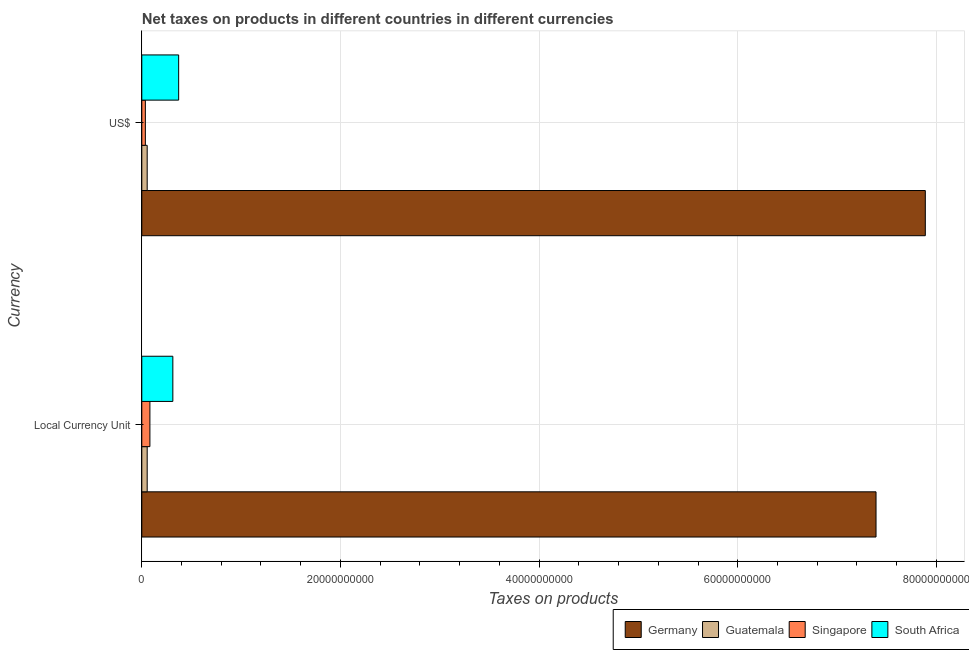How many different coloured bars are there?
Give a very brief answer. 4. Are the number of bars per tick equal to the number of legend labels?
Provide a short and direct response. Yes. How many bars are there on the 1st tick from the top?
Keep it short and to the point. 4. How many bars are there on the 2nd tick from the bottom?
Your answer should be compact. 4. What is the label of the 2nd group of bars from the top?
Make the answer very short. Local Currency Unit. What is the net taxes in us$ in Germany?
Make the answer very short. 7.89e+1. Across all countries, what is the maximum net taxes in us$?
Give a very brief answer. 7.89e+1. Across all countries, what is the minimum net taxes in us$?
Keep it short and to the point. 3.59e+08. In which country was the net taxes in us$ maximum?
Offer a terse response. Germany. In which country was the net taxes in constant 2005 us$ minimum?
Provide a short and direct response. Guatemala. What is the total net taxes in constant 2005 us$ in the graph?
Offer a very short reply. 7.84e+1. What is the difference between the net taxes in us$ in Germany and that in Guatemala?
Your answer should be very brief. 7.83e+1. What is the difference between the net taxes in us$ in Germany and the net taxes in constant 2005 us$ in South Africa?
Give a very brief answer. 7.58e+1. What is the average net taxes in us$ per country?
Offer a terse response. 2.09e+1. What is the difference between the net taxes in us$ and net taxes in constant 2005 us$ in Germany?
Offer a terse response. 4.96e+09. In how many countries, is the net taxes in constant 2005 us$ greater than 4000000000 units?
Ensure brevity in your answer.  1. What is the ratio of the net taxes in us$ in Guatemala to that in South Africa?
Offer a very short reply. 0.15. Is the net taxes in us$ in Singapore less than that in Germany?
Your answer should be compact. Yes. What does the 4th bar from the top in US$ represents?
Provide a succinct answer. Germany. What does the 2nd bar from the bottom in Local Currency Unit represents?
Offer a very short reply. Guatemala. How many countries are there in the graph?
Ensure brevity in your answer.  4. Where does the legend appear in the graph?
Offer a very short reply. Bottom right. How many legend labels are there?
Provide a short and direct response. 4. What is the title of the graph?
Offer a very short reply. Net taxes on products in different countries in different currencies. What is the label or title of the X-axis?
Offer a terse response. Taxes on products. What is the label or title of the Y-axis?
Your response must be concise. Currency. What is the Taxes on products in Germany in Local Currency Unit?
Give a very brief answer. 7.39e+1. What is the Taxes on products of Guatemala in Local Currency Unit?
Your answer should be very brief. 5.43e+08. What is the Taxes on products in Singapore in Local Currency Unit?
Ensure brevity in your answer.  8.16e+08. What is the Taxes on products of South Africa in Local Currency Unit?
Your response must be concise. 3.12e+09. What is the Taxes on products of Germany in US$?
Ensure brevity in your answer.  7.89e+1. What is the Taxes on products of Guatemala in US$?
Your answer should be compact. 5.43e+08. What is the Taxes on products of Singapore in US$?
Provide a short and direct response. 3.59e+08. What is the Taxes on products in South Africa in US$?
Make the answer very short. 3.71e+09. Across all Currency, what is the maximum Taxes on products in Germany?
Your answer should be compact. 7.89e+1. Across all Currency, what is the maximum Taxes on products in Guatemala?
Give a very brief answer. 5.43e+08. Across all Currency, what is the maximum Taxes on products of Singapore?
Offer a terse response. 8.16e+08. Across all Currency, what is the maximum Taxes on products in South Africa?
Offer a very short reply. 3.71e+09. Across all Currency, what is the minimum Taxes on products of Germany?
Ensure brevity in your answer.  7.39e+1. Across all Currency, what is the minimum Taxes on products of Guatemala?
Provide a short and direct response. 5.43e+08. Across all Currency, what is the minimum Taxes on products of Singapore?
Give a very brief answer. 3.59e+08. Across all Currency, what is the minimum Taxes on products of South Africa?
Ensure brevity in your answer.  3.12e+09. What is the total Taxes on products in Germany in the graph?
Your response must be concise. 1.53e+11. What is the total Taxes on products in Guatemala in the graph?
Your answer should be very brief. 1.09e+09. What is the total Taxes on products of Singapore in the graph?
Your answer should be very brief. 1.17e+09. What is the total Taxes on products in South Africa in the graph?
Keep it short and to the point. 6.84e+09. What is the difference between the Taxes on products of Germany in Local Currency Unit and that in US$?
Your answer should be very brief. -4.96e+09. What is the difference between the Taxes on products in Guatemala in Local Currency Unit and that in US$?
Ensure brevity in your answer.  0. What is the difference between the Taxes on products in Singapore in Local Currency Unit and that in US$?
Your response must be concise. 4.57e+08. What is the difference between the Taxes on products in South Africa in Local Currency Unit and that in US$?
Your answer should be compact. -5.86e+08. What is the difference between the Taxes on products of Germany in Local Currency Unit and the Taxes on products of Guatemala in US$?
Your answer should be very brief. 7.34e+1. What is the difference between the Taxes on products in Germany in Local Currency Unit and the Taxes on products in Singapore in US$?
Make the answer very short. 7.36e+1. What is the difference between the Taxes on products in Germany in Local Currency Unit and the Taxes on products in South Africa in US$?
Keep it short and to the point. 7.02e+1. What is the difference between the Taxes on products in Guatemala in Local Currency Unit and the Taxes on products in Singapore in US$?
Make the answer very short. 1.84e+08. What is the difference between the Taxes on products of Guatemala in Local Currency Unit and the Taxes on products of South Africa in US$?
Your response must be concise. -3.17e+09. What is the difference between the Taxes on products of Singapore in Local Currency Unit and the Taxes on products of South Africa in US$?
Your answer should be very brief. -2.90e+09. What is the average Taxes on products of Germany per Currency?
Offer a terse response. 7.64e+1. What is the average Taxes on products of Guatemala per Currency?
Offer a terse response. 5.43e+08. What is the average Taxes on products of Singapore per Currency?
Give a very brief answer. 5.87e+08. What is the average Taxes on products of South Africa per Currency?
Your answer should be compact. 3.42e+09. What is the difference between the Taxes on products in Germany and Taxes on products in Guatemala in Local Currency Unit?
Make the answer very short. 7.34e+1. What is the difference between the Taxes on products in Germany and Taxes on products in Singapore in Local Currency Unit?
Ensure brevity in your answer.  7.31e+1. What is the difference between the Taxes on products of Germany and Taxes on products of South Africa in Local Currency Unit?
Your answer should be very brief. 7.08e+1. What is the difference between the Taxes on products in Guatemala and Taxes on products in Singapore in Local Currency Unit?
Your answer should be very brief. -2.73e+08. What is the difference between the Taxes on products in Guatemala and Taxes on products in South Africa in Local Currency Unit?
Provide a short and direct response. -2.58e+09. What is the difference between the Taxes on products in Singapore and Taxes on products in South Africa in Local Currency Unit?
Your response must be concise. -2.31e+09. What is the difference between the Taxes on products in Germany and Taxes on products in Guatemala in US$?
Provide a succinct answer. 7.83e+1. What is the difference between the Taxes on products in Germany and Taxes on products in Singapore in US$?
Your response must be concise. 7.85e+1. What is the difference between the Taxes on products in Germany and Taxes on products in South Africa in US$?
Your response must be concise. 7.52e+1. What is the difference between the Taxes on products in Guatemala and Taxes on products in Singapore in US$?
Offer a terse response. 1.84e+08. What is the difference between the Taxes on products in Guatemala and Taxes on products in South Africa in US$?
Offer a terse response. -3.17e+09. What is the difference between the Taxes on products of Singapore and Taxes on products of South Africa in US$?
Provide a short and direct response. -3.35e+09. What is the ratio of the Taxes on products in Germany in Local Currency Unit to that in US$?
Offer a terse response. 0.94. What is the ratio of the Taxes on products of Guatemala in Local Currency Unit to that in US$?
Make the answer very short. 1. What is the ratio of the Taxes on products in Singapore in Local Currency Unit to that in US$?
Your answer should be very brief. 2.27. What is the ratio of the Taxes on products in South Africa in Local Currency Unit to that in US$?
Ensure brevity in your answer.  0.84. What is the difference between the highest and the second highest Taxes on products in Germany?
Your response must be concise. 4.96e+09. What is the difference between the highest and the second highest Taxes on products in Singapore?
Provide a succinct answer. 4.57e+08. What is the difference between the highest and the second highest Taxes on products of South Africa?
Your answer should be very brief. 5.86e+08. What is the difference between the highest and the lowest Taxes on products of Germany?
Make the answer very short. 4.96e+09. What is the difference between the highest and the lowest Taxes on products of Guatemala?
Offer a very short reply. 0. What is the difference between the highest and the lowest Taxes on products in Singapore?
Give a very brief answer. 4.57e+08. What is the difference between the highest and the lowest Taxes on products in South Africa?
Keep it short and to the point. 5.86e+08. 